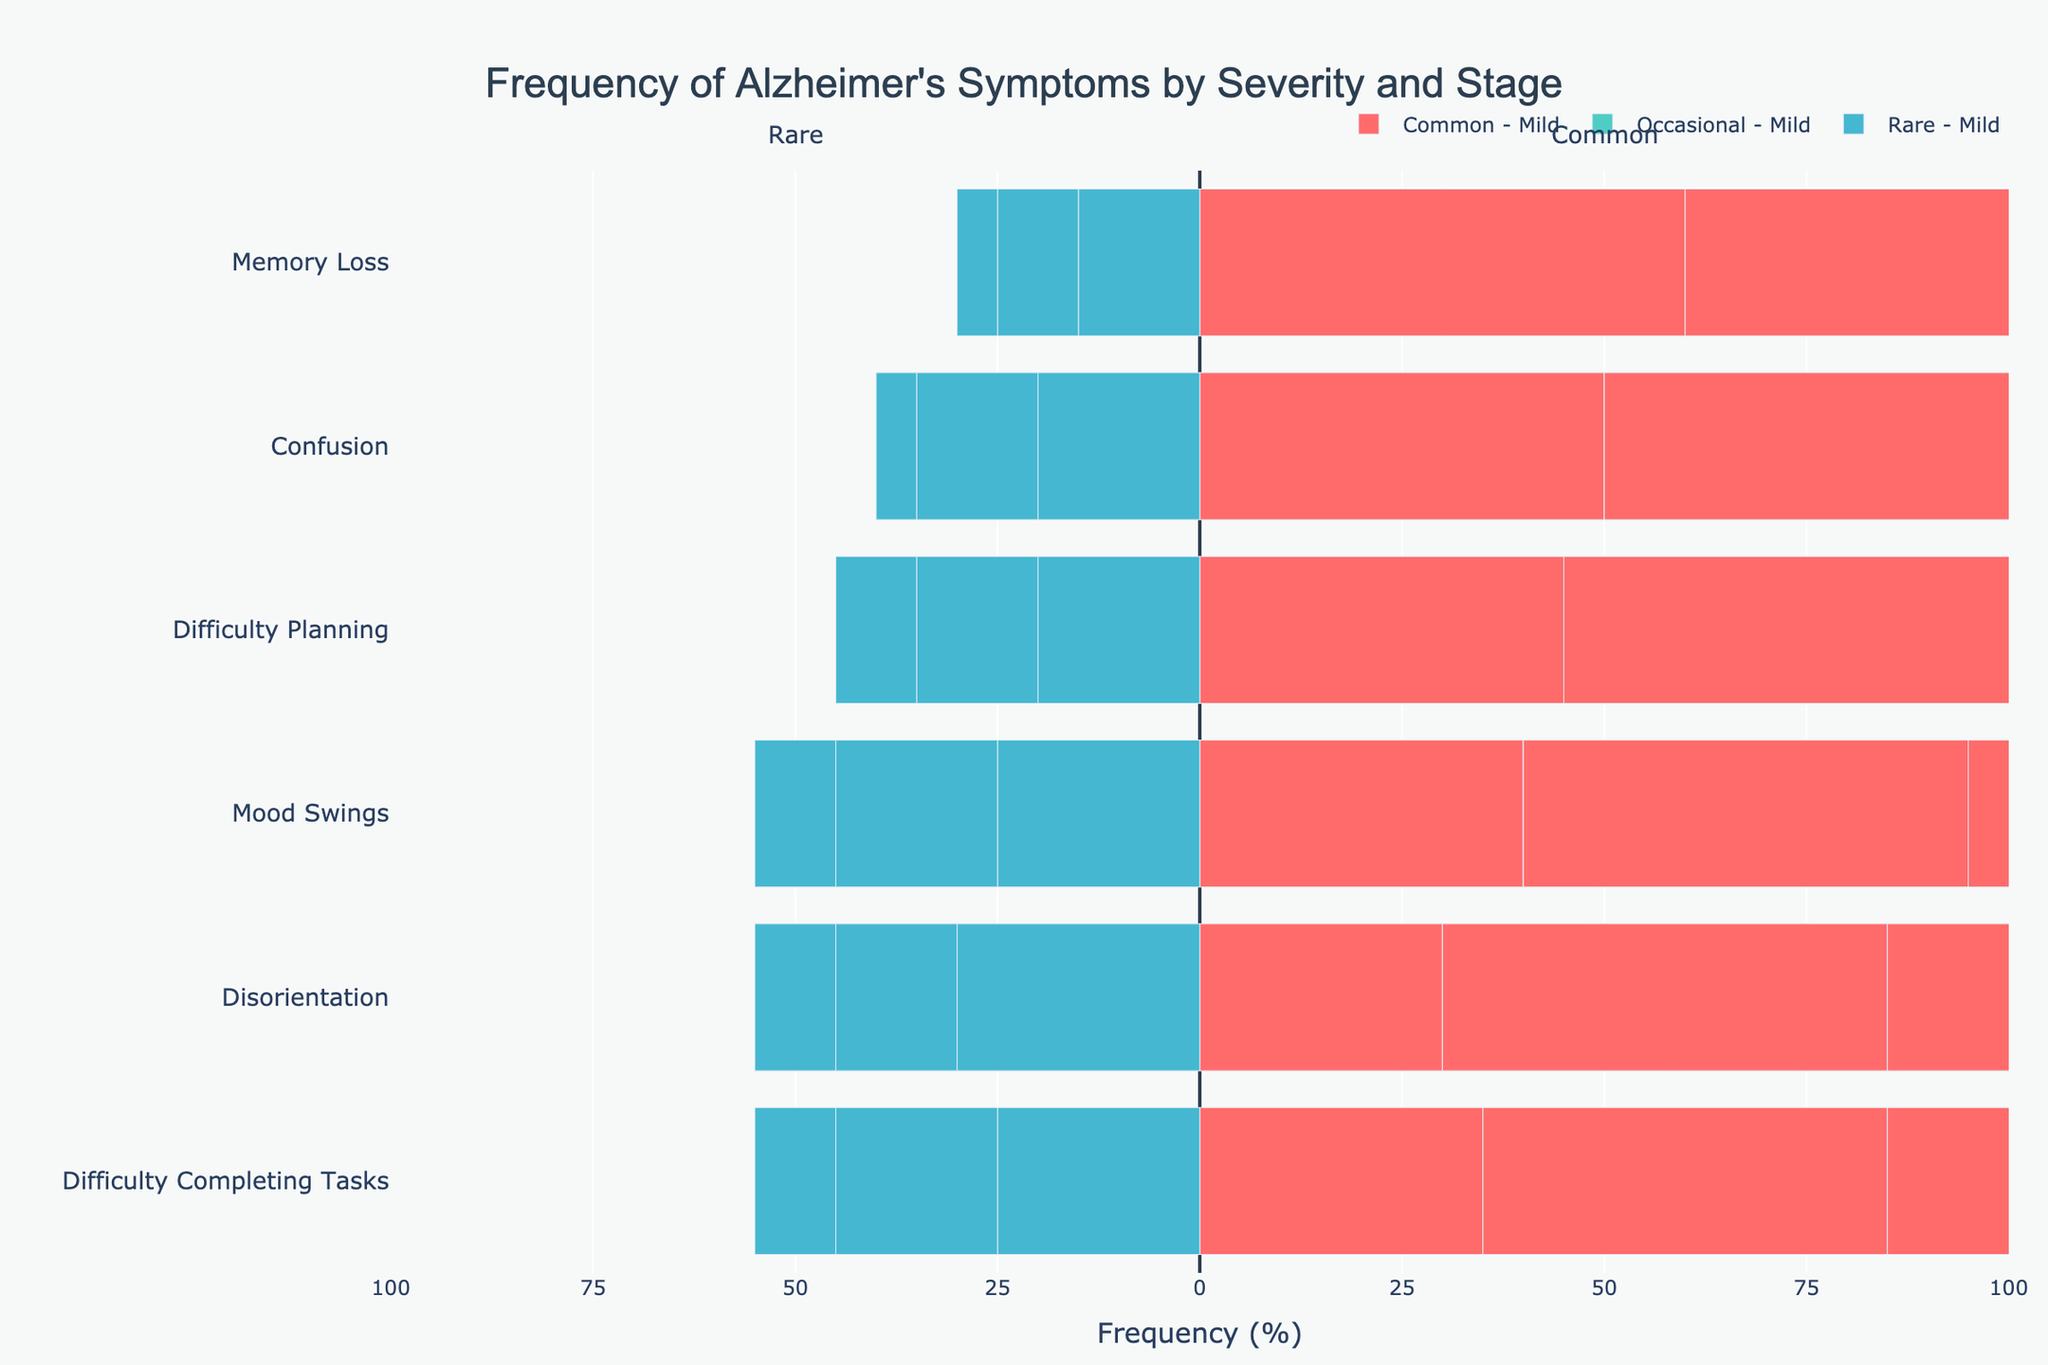which symptom shows the highest percentage of common occurrence in the severe stage? First, look at the red bars labeled "Common - Severe." The longest bar represents the highest percentage. For the severe stage, the symptom with the longest red bar is "Memory Loss" at 85%.
Answer: Memory Loss which symptom has the highest rate of rare occurrence in the mild stage? To answer this, look at the blue bars labeled "Rare - Mild." The longest blue bar indicates the highest rate. The symptom with the longest blue bar in the mild stage is "Disorientation" at 30%.
Answer: Disorientation what's the difference in percentages between common and occasional Memory Loss in the moderate stage? Check the bars for "Memory Loss" in the moderate stage. The red bar represents common occurrences (75%), and the green bar represents occasional occurrences (15%). The difference is 75% - 15% = 60%.
Answer: 60% which stage shows the highest level of common confusion occurrence, and what percentage is it? Look at the red bars for "Confusion" across all stages. The longest red bar is in the severe stage, showing a percentage of 80%.
Answer: Severe, 80% what is the percentage sum of common and occasional mood swings in the mild stage? For "Mood Swings" in the mild stage, the red bar (common) is at 40%, and the green bar (occasional) is at 35%. The sum is 40% + 35% = 75%.
Answer: 75% in which stage and symptoms do rare occurrences never go above 10%? Focus on the blue bars under 10% across all stages and symptoms. The severe stage for "Memory Loss," "Confusion," and "Mood Swings" each have rare occurrences at or below 10%.
Answer: Severe stage for Memory Loss, Confusion, and Mood Swings which symptom shows more frequent common occurrence in the severe stage than in the moderate stage? Compare the red bars for the severe and moderate stages. "Memory Loss" (85% severe vs. 75% moderate), "Confusion" (80% severe vs. 65% moderate), "Mood Swings" (75% severe vs. 55% moderate), and "Difficulty Completing Tasks" (65% severe vs. 50% moderate) all show this pattern.
Answer: Memory Loss, Confusion, Mood Swings, Difficulty Completing Tasks what's the visual relationship between the occurrence rates of common disorientation and occasional disorientation in the moderate stage? For "Disorientation" in the moderate stage, compare the lengths of the red bar (common) and the green bar (occasional). The red bar for common disorientation is longer, indicating a higher rate at 55% compared to the occasional rate of 30%.
Answer: Common is higher than occasional 